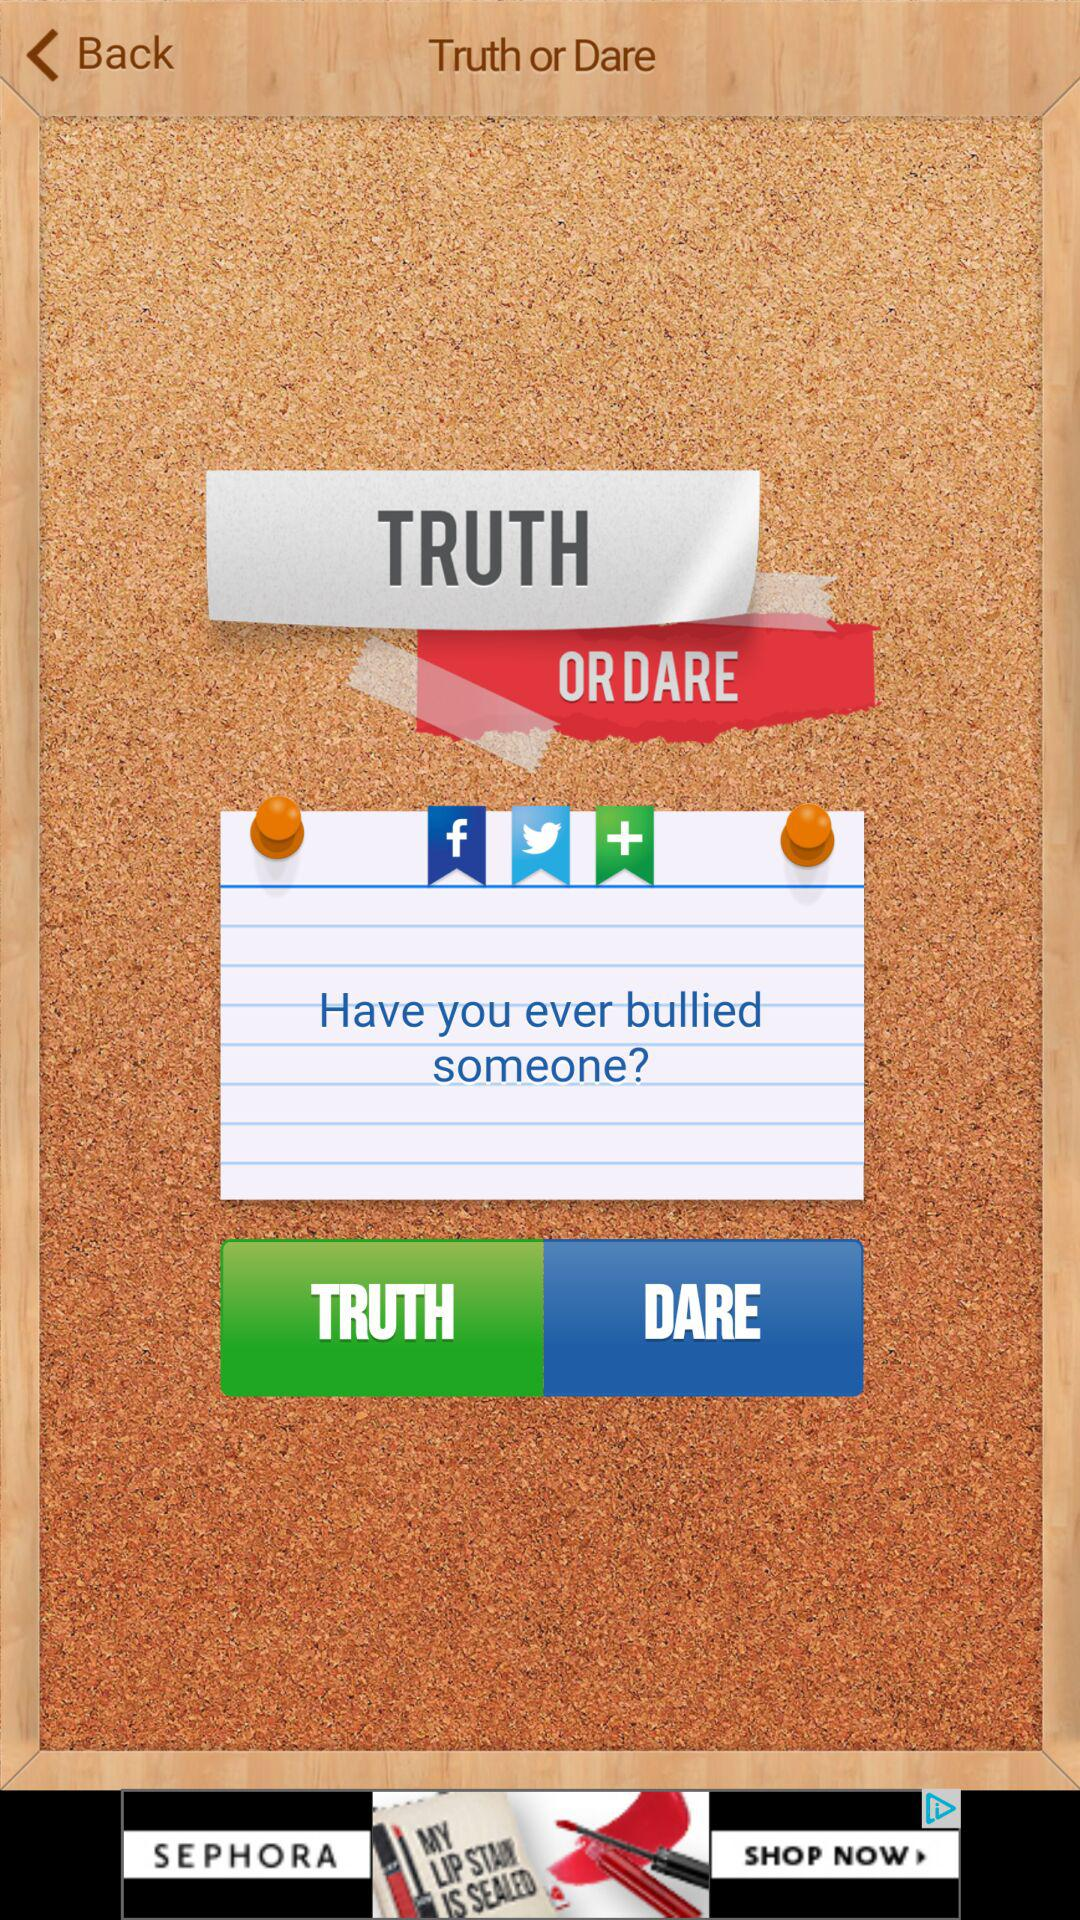What is the application name? The application name is "Truth or Dare". 